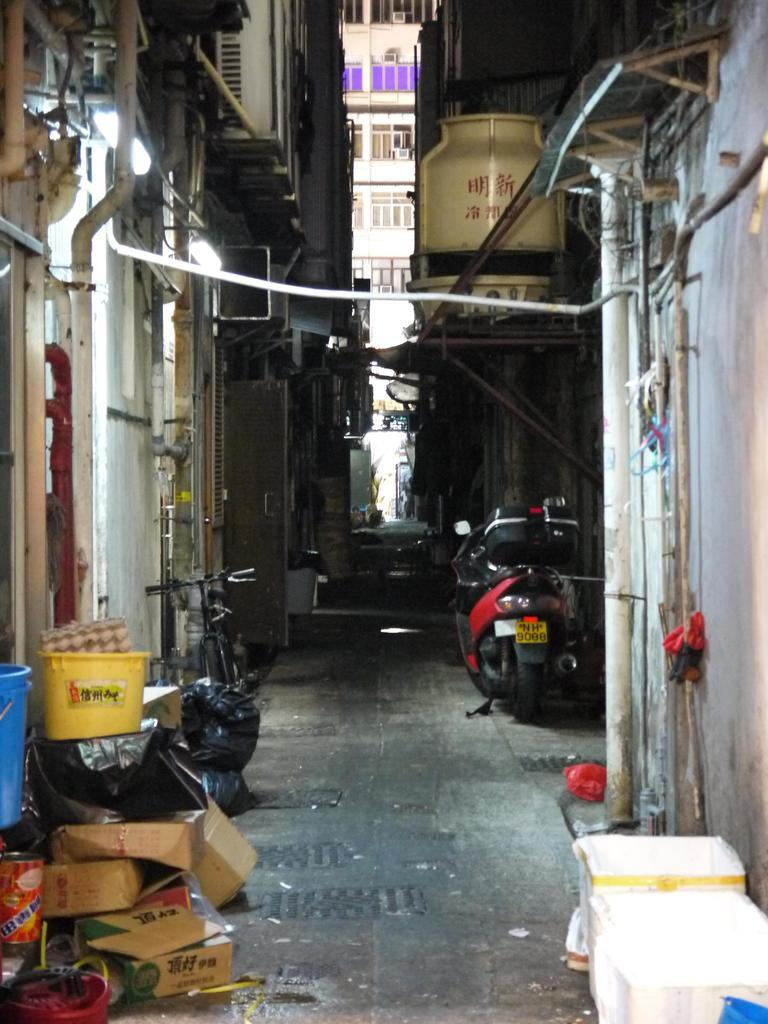What type of vehicles are present in the image? There is a motorcycle and a bicycle in the image. What items are related to storage or packaging in the image? There are cotton boxes, a basket, a bucket, and polythene covers in the image. What architectural features can be seen in the image? There is a door, lights, buildings, and pipes in the image. Can you describe any unspecified objects in the image? There are some unspecified objects in the image, but their purpose or appearance cannot be determined from the provided facts. What type of cushion is being used to make a statement in the image? There is no cushion or statement present in the image. What type of can is visible in the image? There is no can present in the image. 